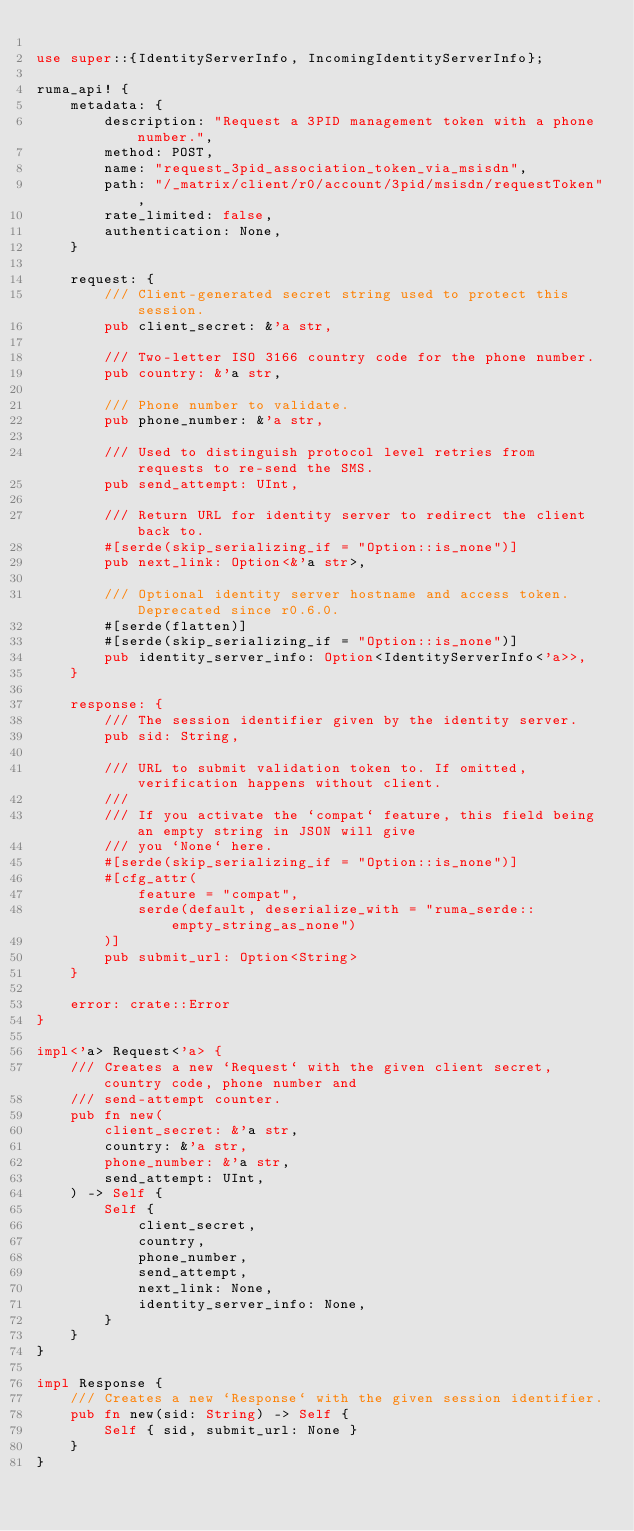Convert code to text. <code><loc_0><loc_0><loc_500><loc_500><_Rust_>
use super::{IdentityServerInfo, IncomingIdentityServerInfo};

ruma_api! {
    metadata: {
        description: "Request a 3PID management token with a phone number.",
        method: POST,
        name: "request_3pid_association_token_via_msisdn",
        path: "/_matrix/client/r0/account/3pid/msisdn/requestToken",
        rate_limited: false,
        authentication: None,
    }

    request: {
        /// Client-generated secret string used to protect this session.
        pub client_secret: &'a str,

        /// Two-letter ISO 3166 country code for the phone number.
        pub country: &'a str,

        /// Phone number to validate.
        pub phone_number: &'a str,

        /// Used to distinguish protocol level retries from requests to re-send the SMS.
        pub send_attempt: UInt,

        /// Return URL for identity server to redirect the client back to.
        #[serde(skip_serializing_if = "Option::is_none")]
        pub next_link: Option<&'a str>,

        /// Optional identity server hostname and access token. Deprecated since r0.6.0.
        #[serde(flatten)]
        #[serde(skip_serializing_if = "Option::is_none")]
        pub identity_server_info: Option<IdentityServerInfo<'a>>,
    }

    response: {
        /// The session identifier given by the identity server.
        pub sid: String,

        /// URL to submit validation token to. If omitted, verification happens without client.
        ///
        /// If you activate the `compat` feature, this field being an empty string in JSON will give
        /// you `None` here.
        #[serde(skip_serializing_if = "Option::is_none")]
        #[cfg_attr(
            feature = "compat",
            serde(default, deserialize_with = "ruma_serde::empty_string_as_none")
        )]
        pub submit_url: Option<String>
    }

    error: crate::Error
}

impl<'a> Request<'a> {
    /// Creates a new `Request` with the given client secret, country code, phone number and
    /// send-attempt counter.
    pub fn new(
        client_secret: &'a str,
        country: &'a str,
        phone_number: &'a str,
        send_attempt: UInt,
    ) -> Self {
        Self {
            client_secret,
            country,
            phone_number,
            send_attempt,
            next_link: None,
            identity_server_info: None,
        }
    }
}

impl Response {
    /// Creates a new `Response` with the given session identifier.
    pub fn new(sid: String) -> Self {
        Self { sid, submit_url: None }
    }
}
</code> 